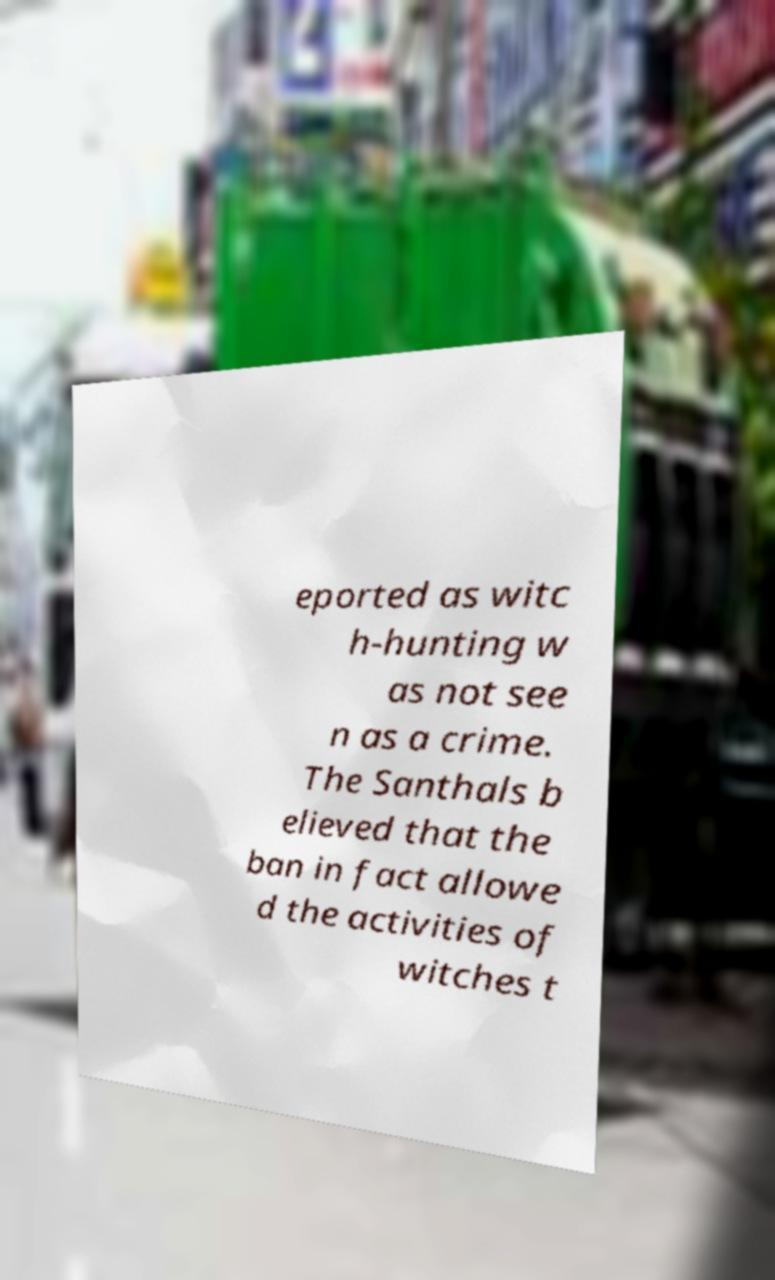Could you assist in decoding the text presented in this image and type it out clearly? eported as witc h-hunting w as not see n as a crime. The Santhals b elieved that the ban in fact allowe d the activities of witches t 